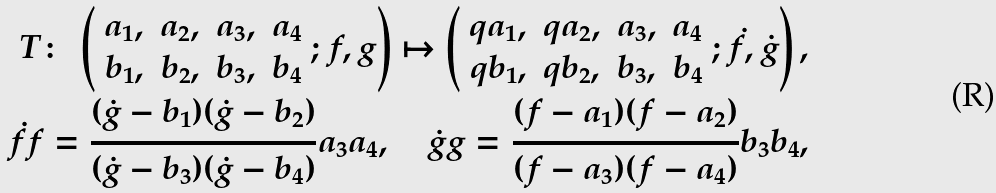Convert formula to latex. <formula><loc_0><loc_0><loc_500><loc_500>T \colon \ \left ( \begin{array} { c c c c } a _ { 1 } , & a _ { 2 } , & a _ { 3 } , & a _ { 4 } \\ b _ { 1 } , & b _ { 2 } , & b _ { 3 } , & b _ { 4 } \end{array} ; f , g \right ) \mapsto \left ( \begin{array} { c c c c } q a _ { 1 } , & q a _ { 2 } , & a _ { 3 } , & a _ { 4 } \\ q b _ { 1 } , & q b _ { 2 } , & b _ { 3 } , & b _ { 4 } \end{array} ; \dot { f } , \dot { g } \right ) , \\ \dot { f } { f } = \frac { ( \dot { g } - b _ { 1 } ) ( \dot { g } - b _ { 2 } ) } { ( \dot { g } - b _ { 3 } ) ( \dot { g } - b _ { 4 } ) } a _ { 3 } a _ { 4 } , \quad \dot { g } { g } = \frac { ( { f } - a _ { 1 } ) ( { f } - a _ { 2 } ) } { ( { f } - a _ { 3 } ) ( { f } - a _ { 4 } ) } b _ { 3 } b _ { 4 } ,</formula> 